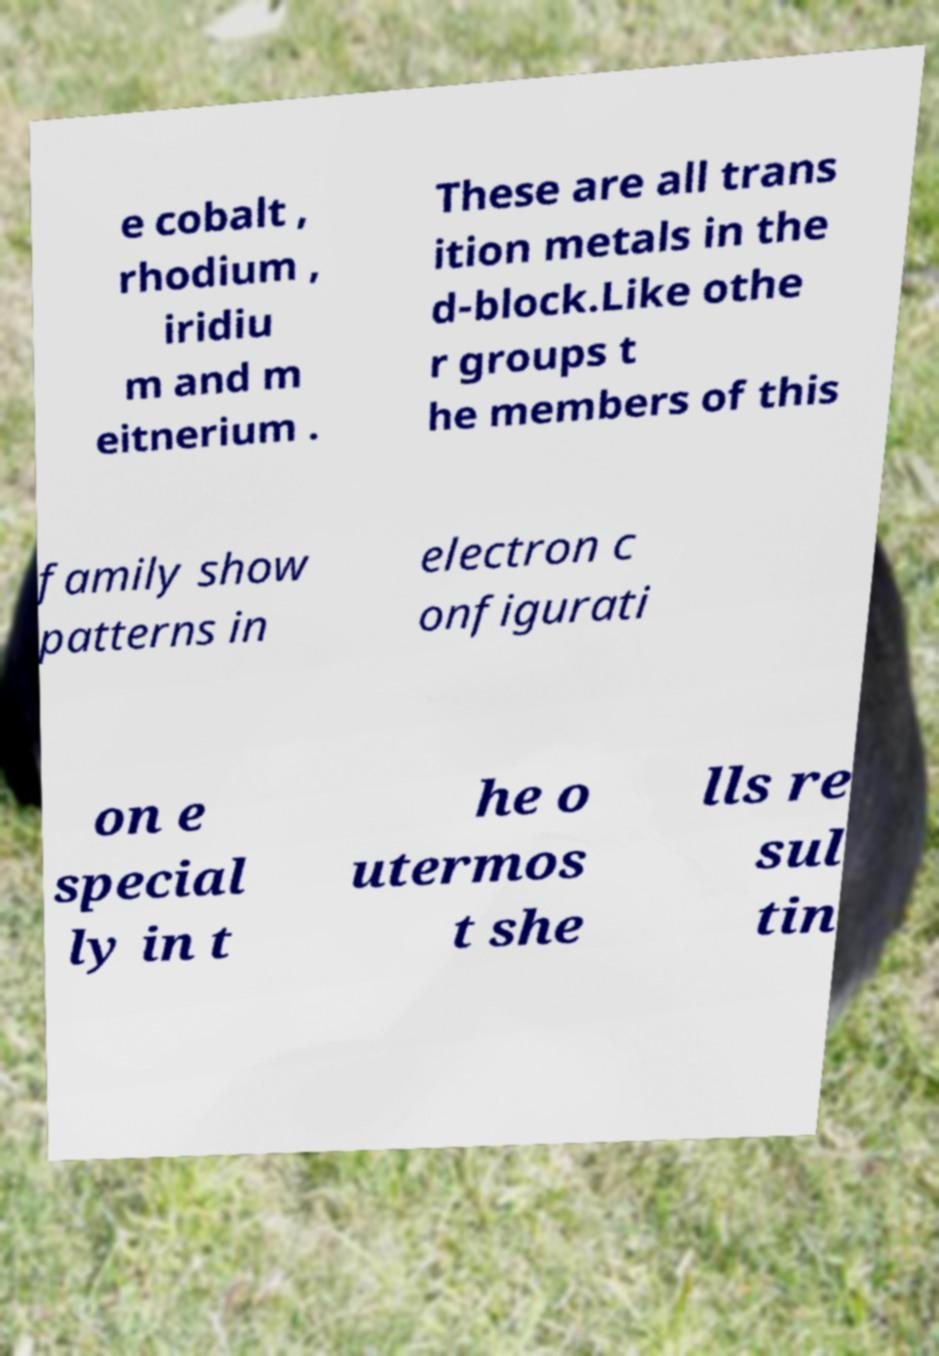There's text embedded in this image that I need extracted. Can you transcribe it verbatim? e cobalt , rhodium , iridiu m and m eitnerium . These are all trans ition metals in the d-block.Like othe r groups t he members of this family show patterns in electron c onfigurati on e special ly in t he o utermos t she lls re sul tin 